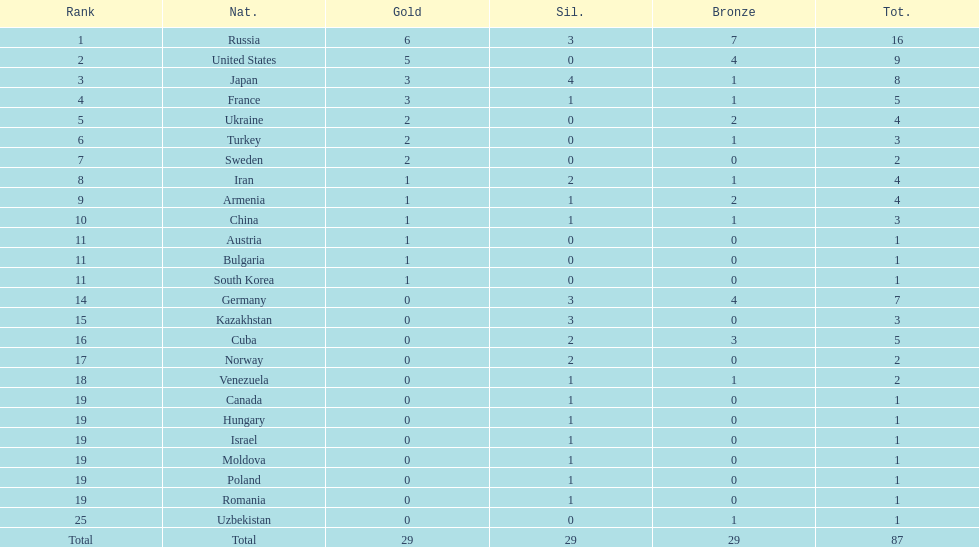Who ranked right after turkey? Sweden. 